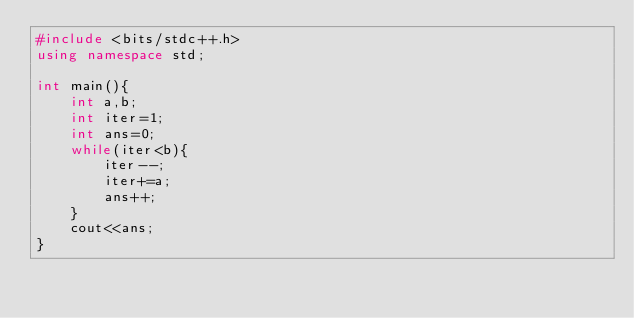Convert code to text. <code><loc_0><loc_0><loc_500><loc_500><_C++_>#include <bits/stdc++.h>
using namespace std;

int main(){
	int a,b;
	int iter=1;
	int ans=0;
	while(iter<b){
		iter--;
		iter+=a;
		ans++;
	}
	cout<<ans;
}</code> 